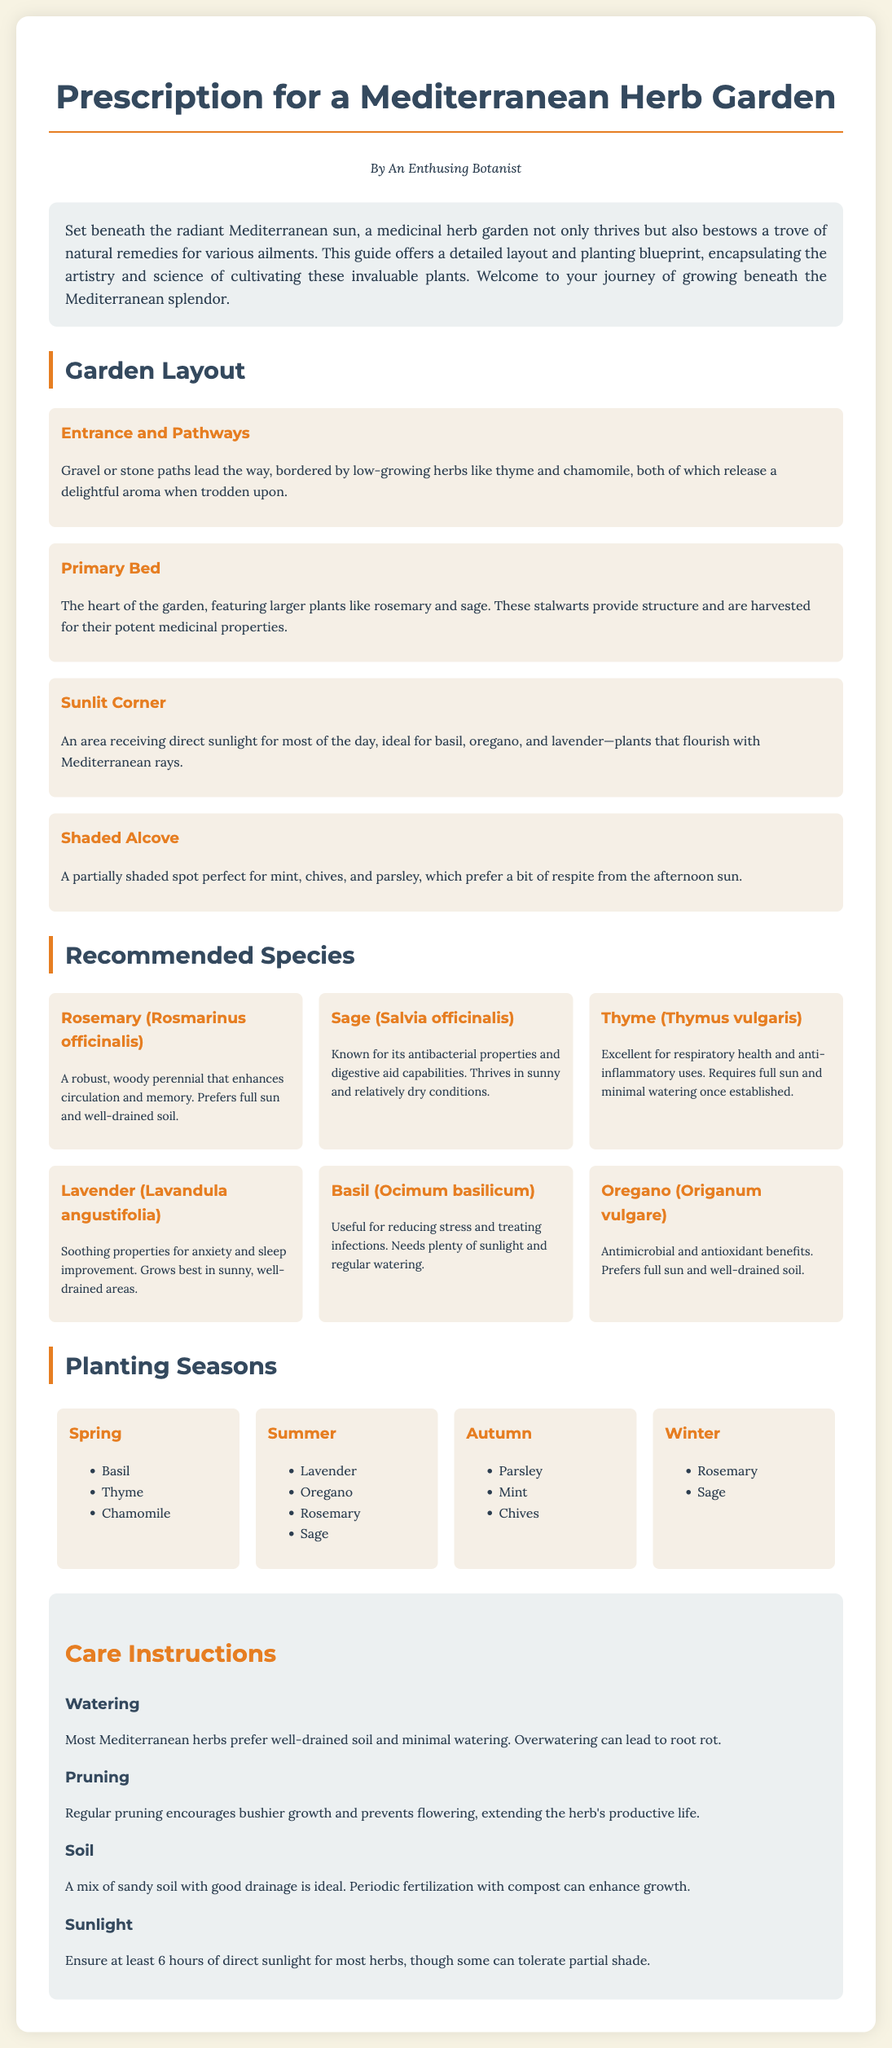What is the title of the document? The title is presented prominently at the top of the document, stating the purpose and content focus.
Answer: Prescription for a Mediterranean Herb Garden Who authored the document? The author is mentioned beneath the title, indicating the creator of the content.
Answer: An Enthusing Botanist What type of soil is ideal for Mediterranean herbs? Specific soil recommendations are provided to support optimal growth of the herbs discussed in the document.
Answer: Sandy soil Which herb prefers well-drained soil and minimal watering? The document specifies characteristics of different herbs, particularly focusing on watering needs.
Answer: Thyme When should basil be planted? The planting seasons are clearly outlined, detailing the appropriate time for each herb type.
Answer: Spring What is the main purpose of the garden layout section? The section describes how to organize the herb garden effectively, focusing on structural elements.
Answer: Organizing the garden What care instruction entails pruning? The care directions elaborate on the importance of specific practices to maintain herb health.
Answer: Regular pruning encourages bushier growth Which herb is mentioned for its soothing properties? The document highlights various herbs and their medicinal uses, encouraging beneficial growth.
Answer: Lavender What herb is recommended for autumn planting? The document lists herbs suitable for each season, ensuring proper planting times.
Answer: Parsley 